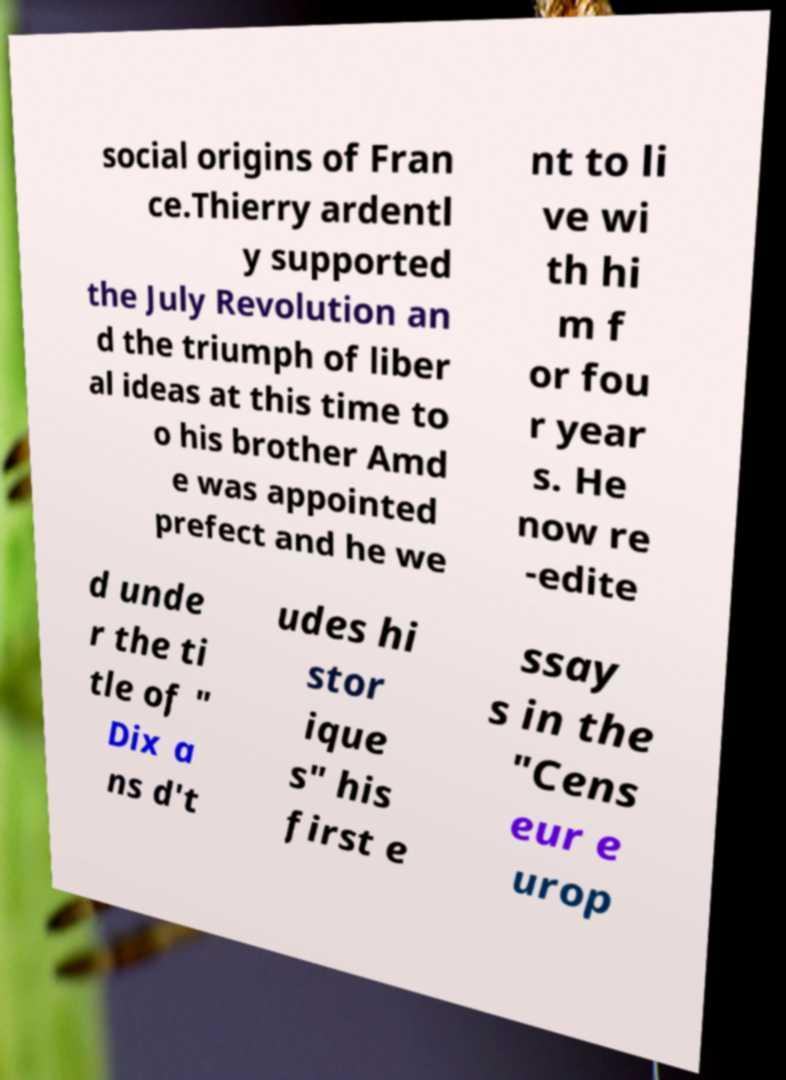I need the written content from this picture converted into text. Can you do that? social origins of Fran ce.Thierry ardentl y supported the July Revolution an d the triumph of liber al ideas at this time to o his brother Amd e was appointed prefect and he we nt to li ve wi th hi m f or fou r year s. He now re -edite d unde r the ti tle of " Dix a ns d't udes hi stor ique s" his first e ssay s in the "Cens eur e urop 